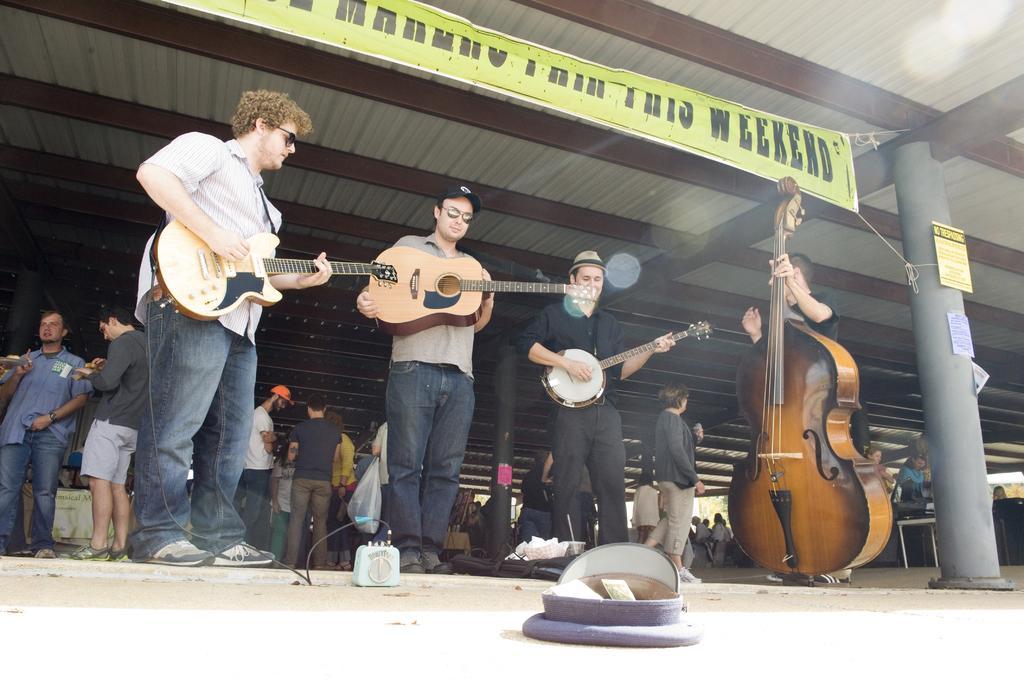In one or two sentences, can you explain what this image depicts? In this image I see 4 men who are standing and holding the musical instruments and there is a banner over here. In the background I see lot of people who are on the path. 